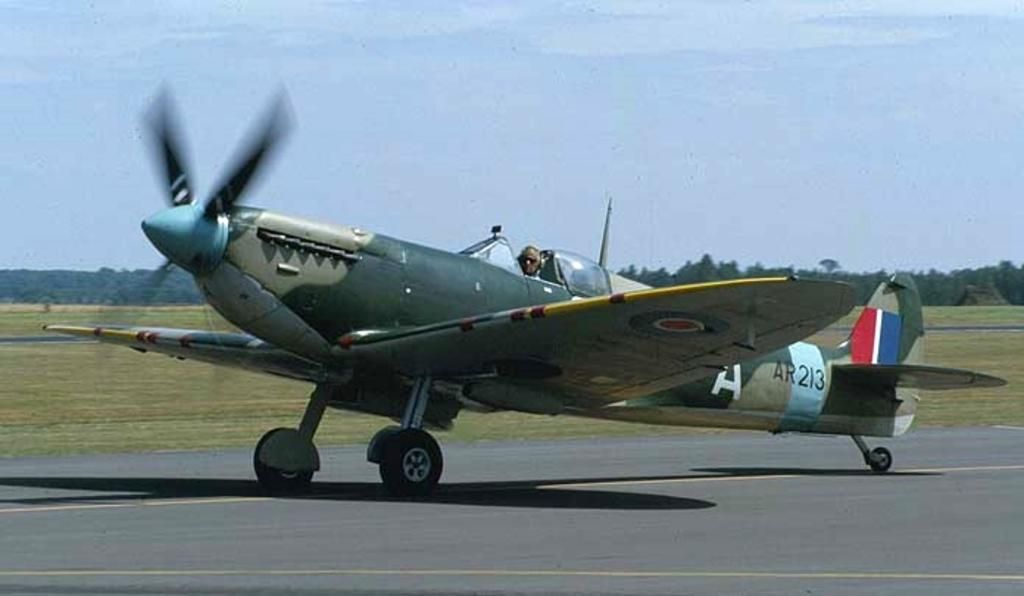<image>
Write a terse but informative summary of the picture. a jet plane with AR213 written on the back side of it 